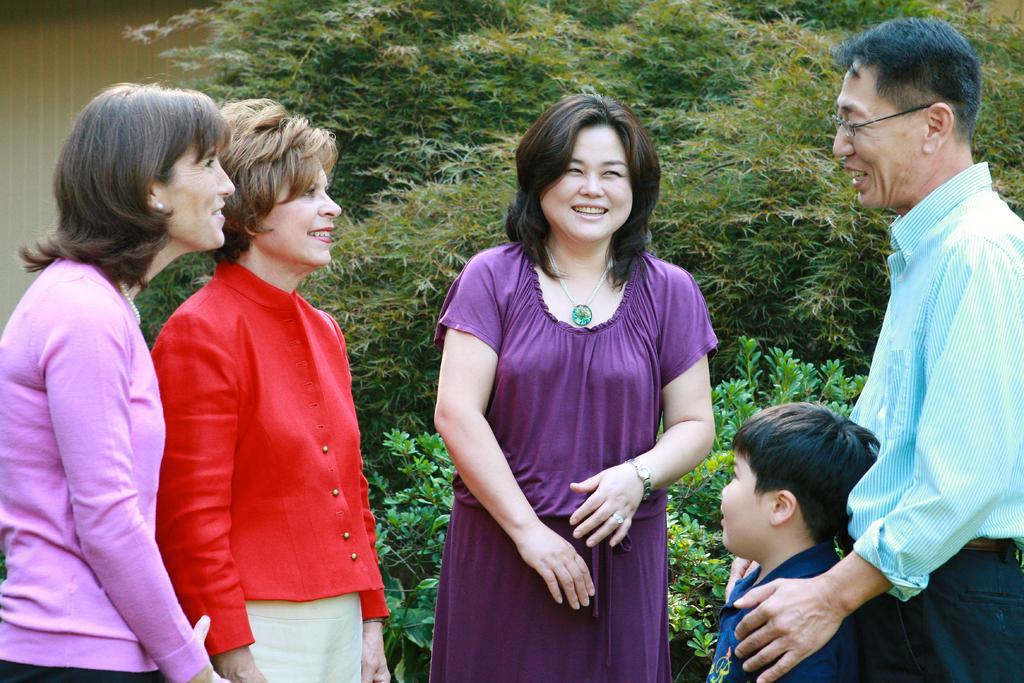Can you describe this image briefly? In this image there are a few people standing. They are smiling. Behind them there are plants. To the left there is a wall. 